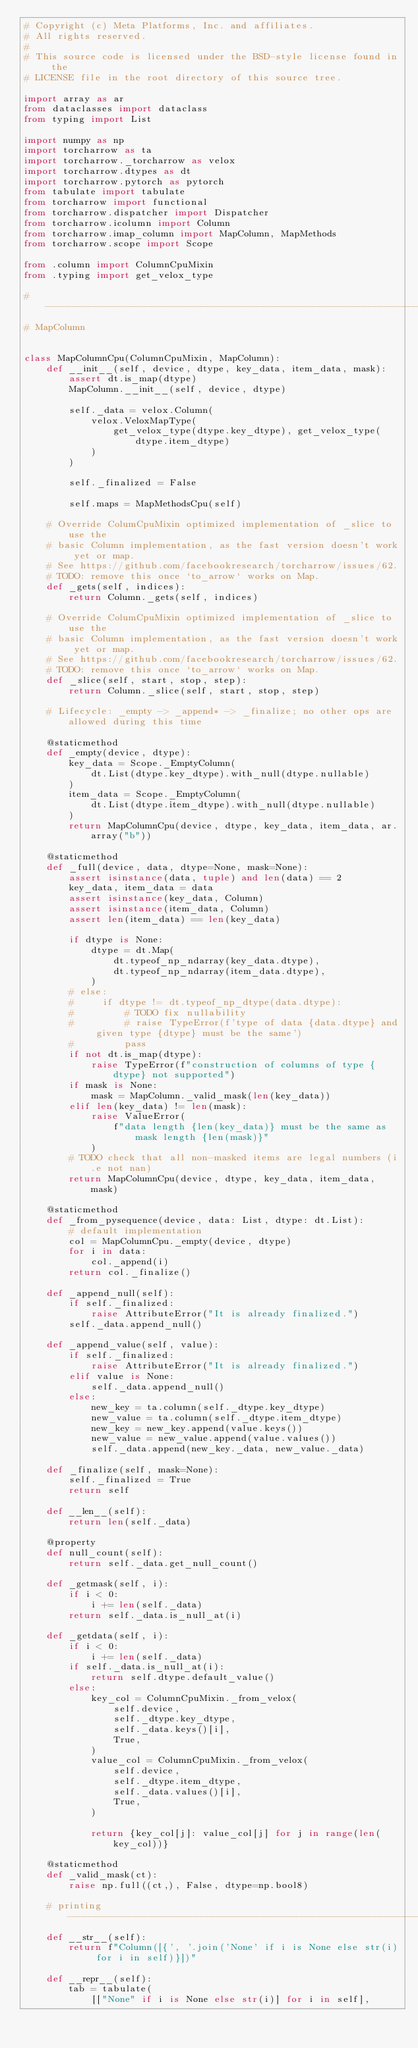<code> <loc_0><loc_0><loc_500><loc_500><_Python_># Copyright (c) Meta Platforms, Inc. and affiliates.
# All rights reserved.
#
# This source code is licensed under the BSD-style license found in the
# LICENSE file in the root directory of this source tree.

import array as ar
from dataclasses import dataclass
from typing import List

import numpy as np
import torcharrow as ta
import torcharrow._torcharrow as velox
import torcharrow.dtypes as dt
import torcharrow.pytorch as pytorch
from tabulate import tabulate
from torcharrow import functional
from torcharrow.dispatcher import Dispatcher
from torcharrow.icolumn import Column
from torcharrow.imap_column import MapColumn, MapMethods
from torcharrow.scope import Scope

from .column import ColumnCpuMixin
from .typing import get_velox_type

# -----------------------------------------------------------------------------
# MapColumn


class MapColumnCpu(ColumnCpuMixin, MapColumn):
    def __init__(self, device, dtype, key_data, item_data, mask):
        assert dt.is_map(dtype)
        MapColumn.__init__(self, device, dtype)

        self._data = velox.Column(
            velox.VeloxMapType(
                get_velox_type(dtype.key_dtype), get_velox_type(dtype.item_dtype)
            )
        )

        self._finalized = False

        self.maps = MapMethodsCpu(self)

    # Override ColumCpuMixin optimized implementation of _slice to use the
    # basic Column implementation, as the fast version doesn't work yet or map.
    # See https://github.com/facebookresearch/torcharrow/issues/62.
    # TODO: remove this once `to_arrow` works on Map.
    def _gets(self, indices):
        return Column._gets(self, indices)

    # Override ColumCpuMixin optimized implementation of _slice to use the
    # basic Column implementation, as the fast version doesn't work yet or map.
    # See https://github.com/facebookresearch/torcharrow/issues/62.
    # TODO: remove this once `to_arrow` works on Map.
    def _slice(self, start, stop, step):
        return Column._slice(self, start, stop, step)

    # Lifecycle: _empty -> _append* -> _finalize; no other ops are allowed during this time

    @staticmethod
    def _empty(device, dtype):
        key_data = Scope._EmptyColumn(
            dt.List(dtype.key_dtype).with_null(dtype.nullable)
        )
        item_data = Scope._EmptyColumn(
            dt.List(dtype.item_dtype).with_null(dtype.nullable)
        )
        return MapColumnCpu(device, dtype, key_data, item_data, ar.array("b"))

    @staticmethod
    def _full(device, data, dtype=None, mask=None):
        assert isinstance(data, tuple) and len(data) == 2
        key_data, item_data = data
        assert isinstance(key_data, Column)
        assert isinstance(item_data, Column)
        assert len(item_data) == len(key_data)

        if dtype is None:
            dtype = dt.Map(
                dt.typeof_np_ndarray(key_data.dtype),
                dt.typeof_np_ndarray(item_data.dtype),
            )
        # else:
        #     if dtype != dt.typeof_np_dtype(data.dtype):
        #         # TODO fix nullability
        #         # raise TypeError(f'type of data {data.dtype} and given type {dtype} must be the same')
        #         pass
        if not dt.is_map(dtype):
            raise TypeError(f"construction of columns of type {dtype} not supported")
        if mask is None:
            mask = MapColumn._valid_mask(len(key_data))
        elif len(key_data) != len(mask):
            raise ValueError(
                f"data length {len(key_data)} must be the same as mask length {len(mask)}"
            )
        # TODO check that all non-masked items are legal numbers (i.e not nan)
        return MapColumnCpu(device, dtype, key_data, item_data, mask)

    @staticmethod
    def _from_pysequence(device, data: List, dtype: dt.List):
        # default implementation
        col = MapColumnCpu._empty(device, dtype)
        for i in data:
            col._append(i)
        return col._finalize()

    def _append_null(self):
        if self._finalized:
            raise AttributeError("It is already finalized.")
        self._data.append_null()

    def _append_value(self, value):
        if self._finalized:
            raise AttributeError("It is already finalized.")
        elif value is None:
            self._data.append_null()
        else:
            new_key = ta.column(self._dtype.key_dtype)
            new_value = ta.column(self._dtype.item_dtype)
            new_key = new_key.append(value.keys())
            new_value = new_value.append(value.values())
            self._data.append(new_key._data, new_value._data)

    def _finalize(self, mask=None):
        self._finalized = True
        return self

    def __len__(self):
        return len(self._data)

    @property
    def null_count(self):
        return self._data.get_null_count()

    def _getmask(self, i):
        if i < 0:
            i += len(self._data)
        return self._data.is_null_at(i)

    def _getdata(self, i):
        if i < 0:
            i += len(self._data)
        if self._data.is_null_at(i):
            return self.dtype.default_value()
        else:
            key_col = ColumnCpuMixin._from_velox(
                self.device,
                self._dtype.key_dtype,
                self._data.keys()[i],
                True,
            )
            value_col = ColumnCpuMixin._from_velox(
                self.device,
                self._dtype.item_dtype,
                self._data.values()[i],
                True,
            )

            return {key_col[j]: value_col[j] for j in range(len(key_col))}

    @staticmethod
    def _valid_mask(ct):
        raise np.full((ct,), False, dtype=np.bool8)

    # printing ----------------------------------------------------------------
    def __str__(self):
        return f"Column([{', '.join('None' if i is None else str(i) for i in self)}])"

    def __repr__(self):
        tab = tabulate(
            [["None" if i is None else str(i)] for i in self],</code> 